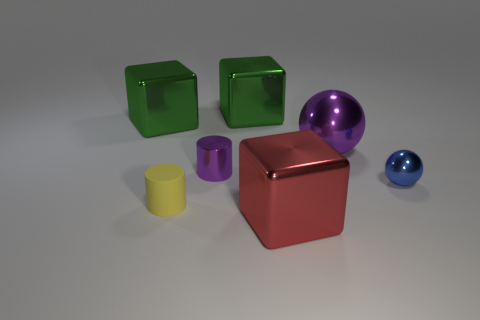How many objects in the image share the same color? Within the image, there are a total of two objects that share the same distinct purple color.  What materials do the objects look like they're made of? The objects in the image seem to be made of a smooth, reflective material that could be plastic or a polished metal, giving them a shiny appearance. 